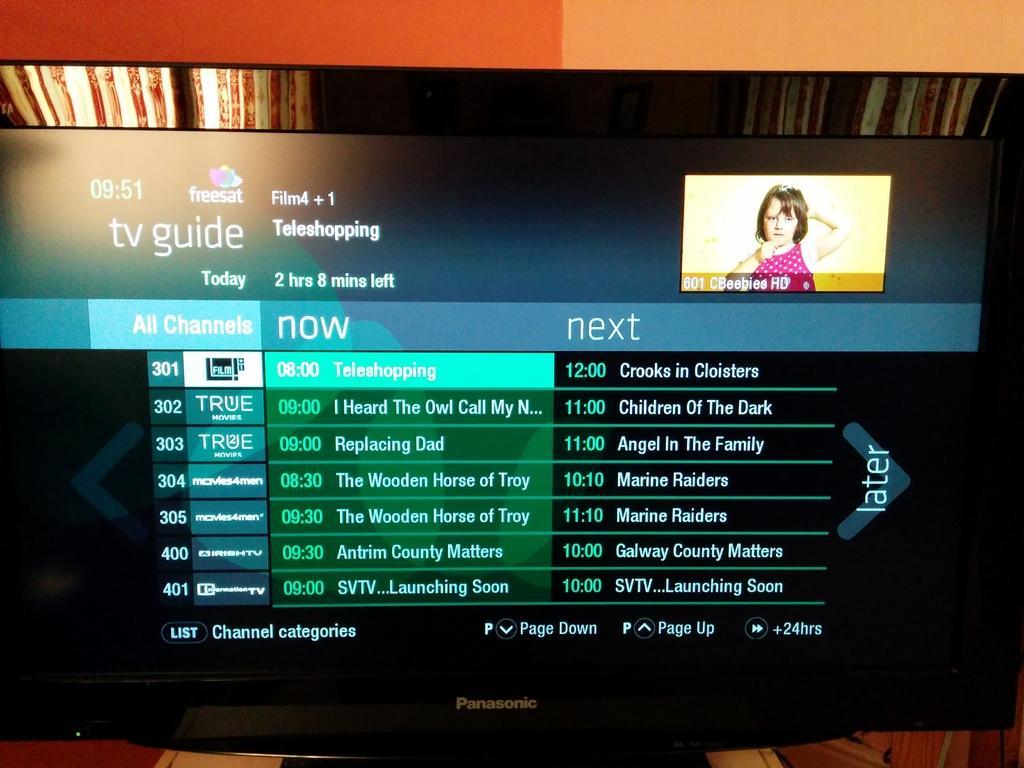How would you summarize this image in a sentence or two? In this picture we can see screen, in this screen we can see a girl and some information. 